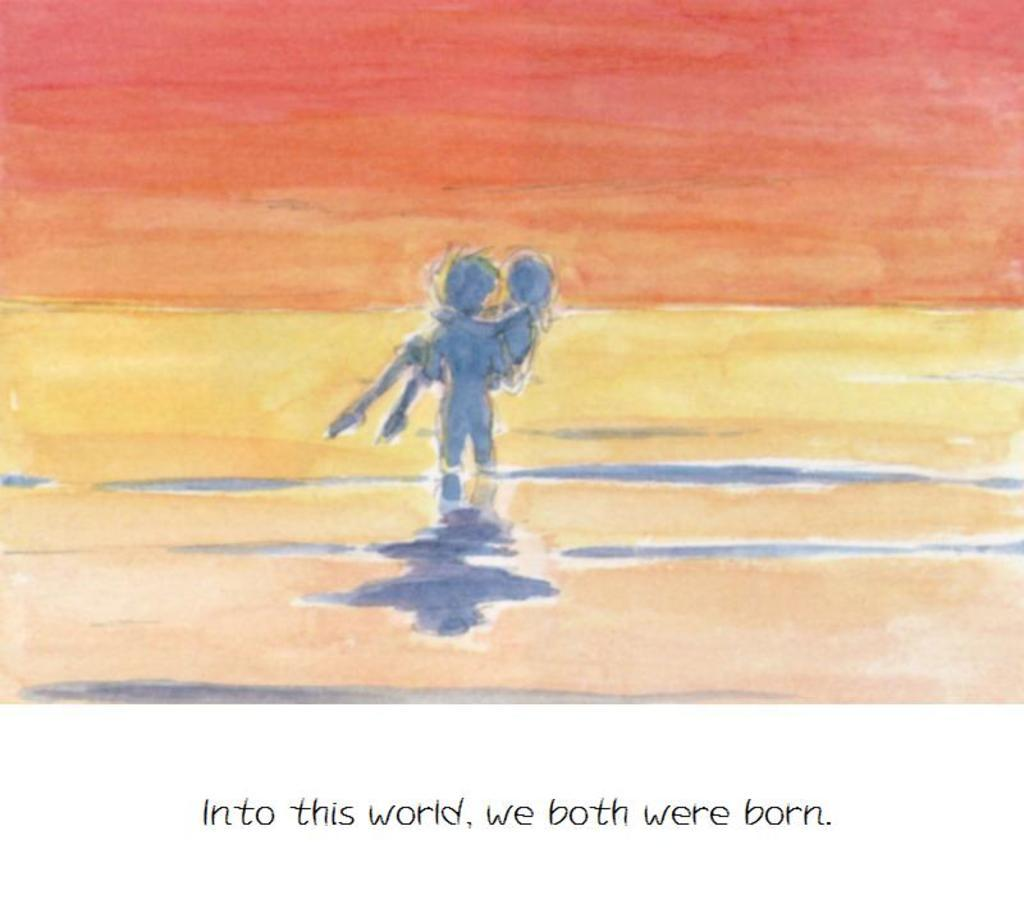What is depicted in the painting in the image? The painting contains a depiction of two persons. What natural element is visible in the image? There is a water body visible in the image. What part of the sky can be seen in the image? The sky is visible in the image. What is written or printed at the bottom of the image? There is some text at the bottom of the image. How many tomatoes are being harvested by the farmer in the image? There is no farmer or tomatoes present in the image; it contains a painting of two persons. What type of tub is visible in the image? There is no tub present in the image. 